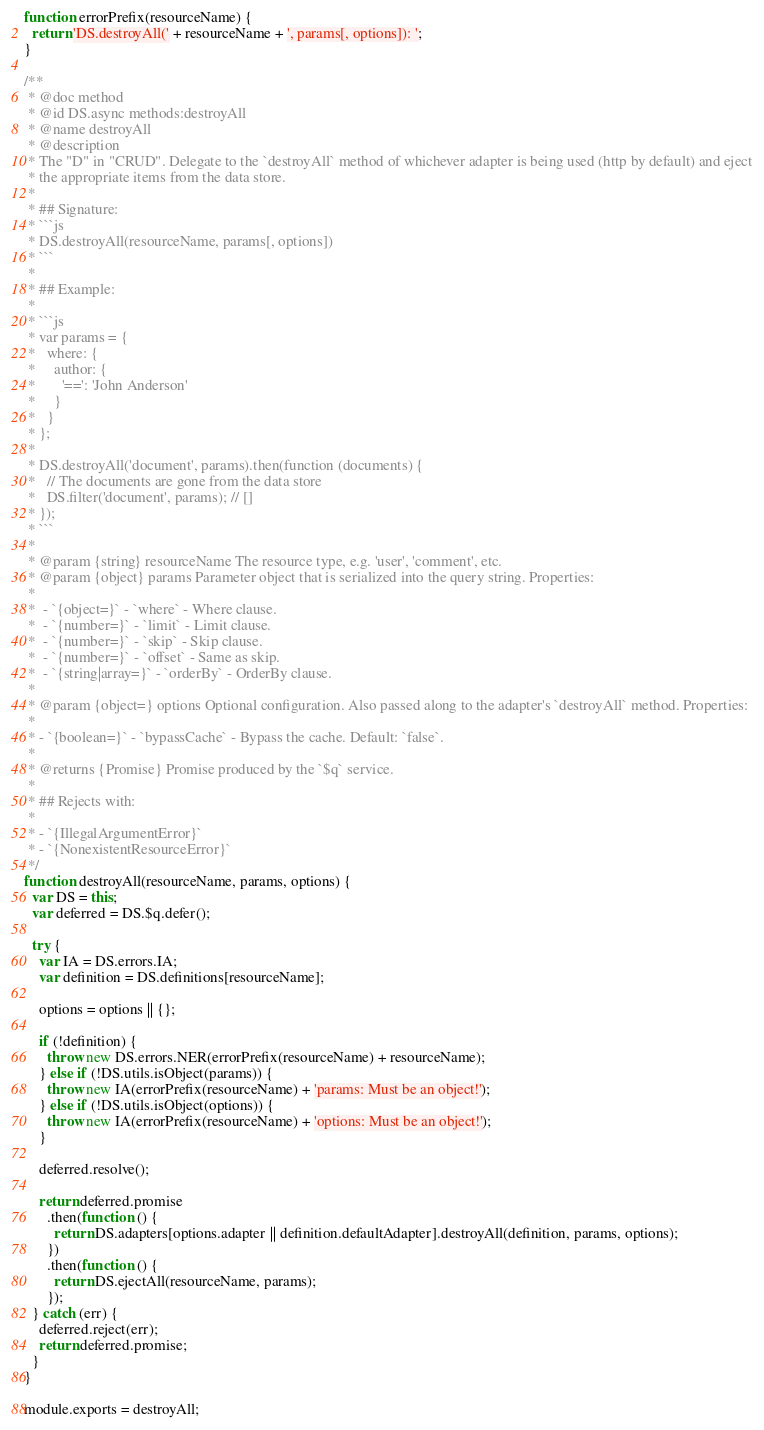Convert code to text. <code><loc_0><loc_0><loc_500><loc_500><_JavaScript_>function errorPrefix(resourceName) {
  return 'DS.destroyAll(' + resourceName + ', params[, options]): ';
}

/**
 * @doc method
 * @id DS.async methods:destroyAll
 * @name destroyAll
 * @description
 * The "D" in "CRUD". Delegate to the `destroyAll` method of whichever adapter is being used (http by default) and eject
 * the appropriate items from the data store.
 *
 * ## Signature:
 * ```js
 * DS.destroyAll(resourceName, params[, options])
 * ```
 *
 * ## Example:
 *
 * ```js
 * var params = {
 *   where: {
 *     author: {
 *       '==': 'John Anderson'
 *     }
 *   }
 * };
 *
 * DS.destroyAll('document', params).then(function (documents) {
 *   // The documents are gone from the data store
 *   DS.filter('document', params); // []
 * });
 * ```
 *
 * @param {string} resourceName The resource type, e.g. 'user', 'comment', etc.
 * @param {object} params Parameter object that is serialized into the query string. Properties:
 *
 *  - `{object=}` - `where` - Where clause.
 *  - `{number=}` - `limit` - Limit clause.
 *  - `{number=}` - `skip` - Skip clause.
 *  - `{number=}` - `offset` - Same as skip.
 *  - `{string|array=}` - `orderBy` - OrderBy clause.
 *
 * @param {object=} options Optional configuration. Also passed along to the adapter's `destroyAll` method. Properties:
 *
 * - `{boolean=}` - `bypassCache` - Bypass the cache. Default: `false`.
 *
 * @returns {Promise} Promise produced by the `$q` service.
 *
 * ## Rejects with:
 *
 * - `{IllegalArgumentError}`
 * - `{NonexistentResourceError}`
 */
function destroyAll(resourceName, params, options) {
  var DS = this;
  var deferred = DS.$q.defer();

  try {
    var IA = DS.errors.IA;
    var definition = DS.definitions[resourceName];

    options = options || {};

    if (!definition) {
      throw new DS.errors.NER(errorPrefix(resourceName) + resourceName);
    } else if (!DS.utils.isObject(params)) {
      throw new IA(errorPrefix(resourceName) + 'params: Must be an object!');
    } else if (!DS.utils.isObject(options)) {
      throw new IA(errorPrefix(resourceName) + 'options: Must be an object!');
    }

    deferred.resolve();

    return deferred.promise
      .then(function () {
        return DS.adapters[options.adapter || definition.defaultAdapter].destroyAll(definition, params, options);
      })
      .then(function () {
        return DS.ejectAll(resourceName, params);
      });
  } catch (err) {
    deferred.reject(err);
    return deferred.promise;
  }
}

module.exports = destroyAll;
</code> 